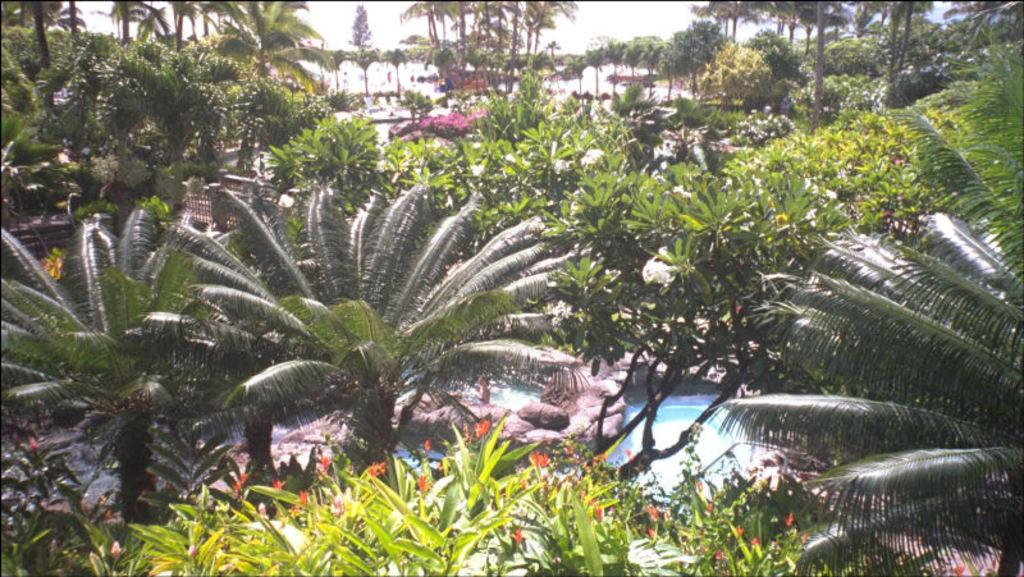What type of natural elements can be seen in the image? There are trees and water visible in the image. What type of objects can be found in the image? There are stones and other objects in the image. What is visible in the background of the image? The sky is visible in the background of the image. Where is the zebra located in the image? There is no zebra present in the image. What type of crate can be seen holding the stones in the image? There is no crate visible in the image; the stones are scattered among other objects. 